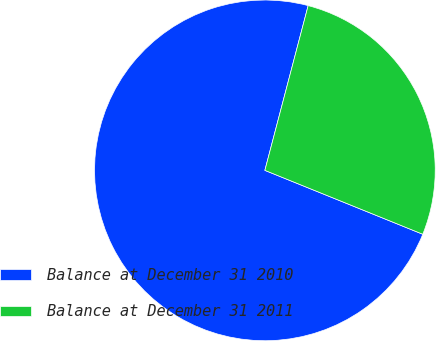Convert chart to OTSL. <chart><loc_0><loc_0><loc_500><loc_500><pie_chart><fcel>Balance at December 31 2010<fcel>Balance at December 31 2011<nl><fcel>72.97%<fcel>27.03%<nl></chart> 